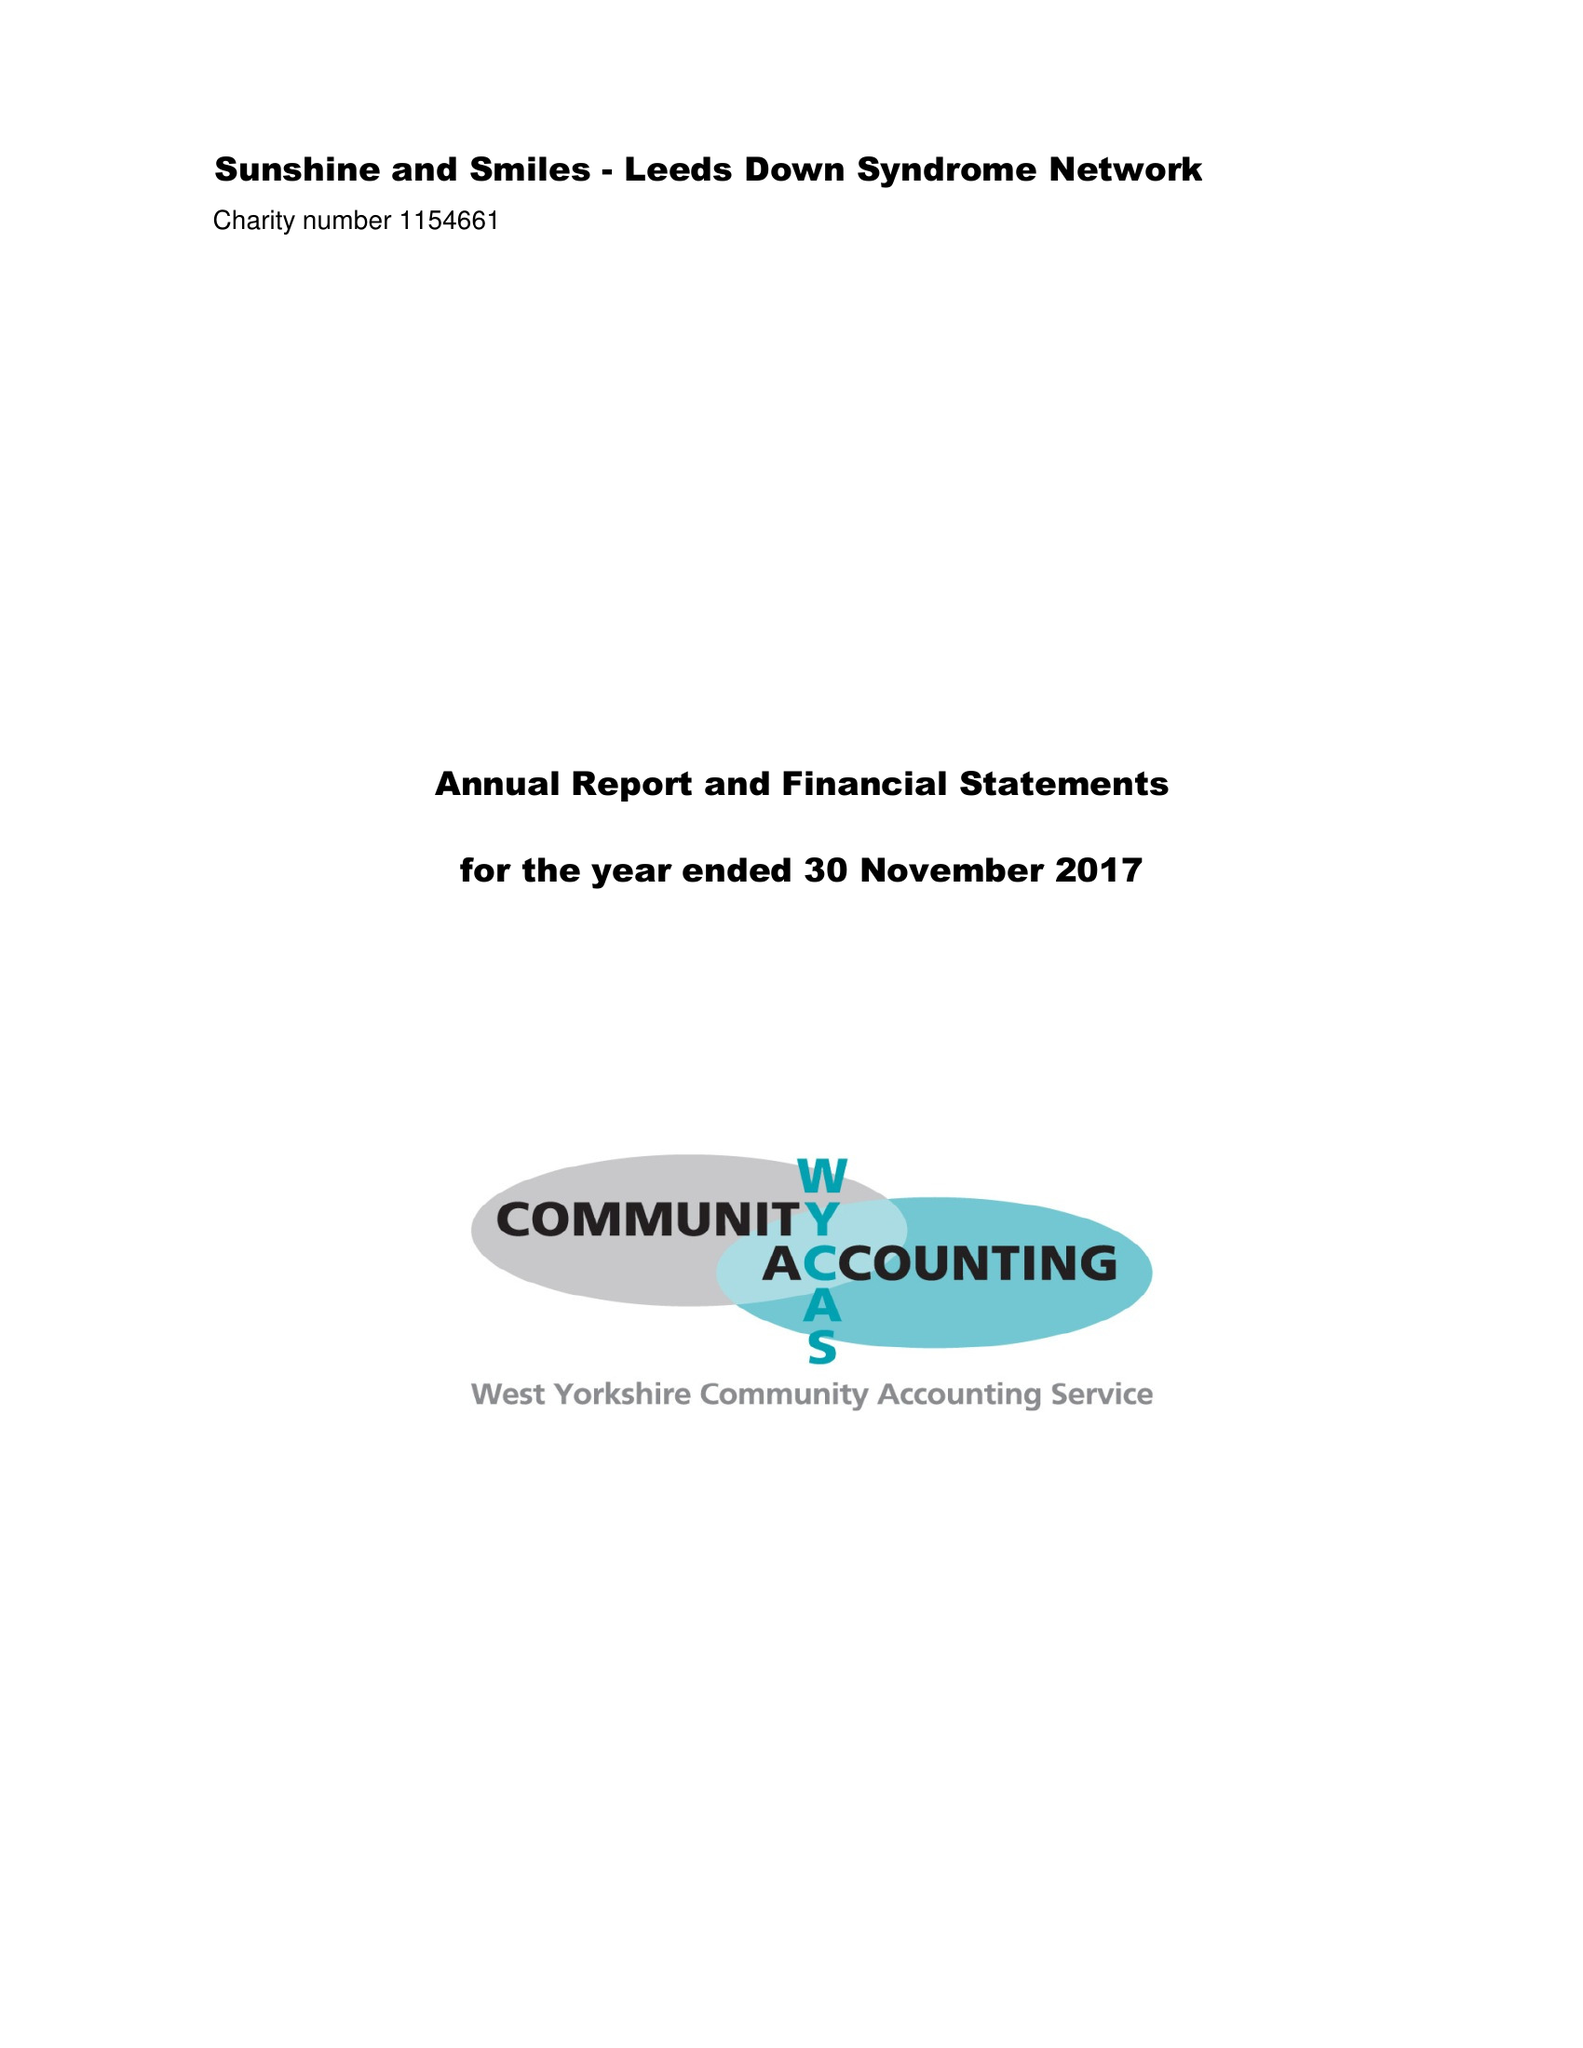What is the value for the address__street_line?
Answer the question using a single word or phrase. 3 DRUMMOND ROAD 